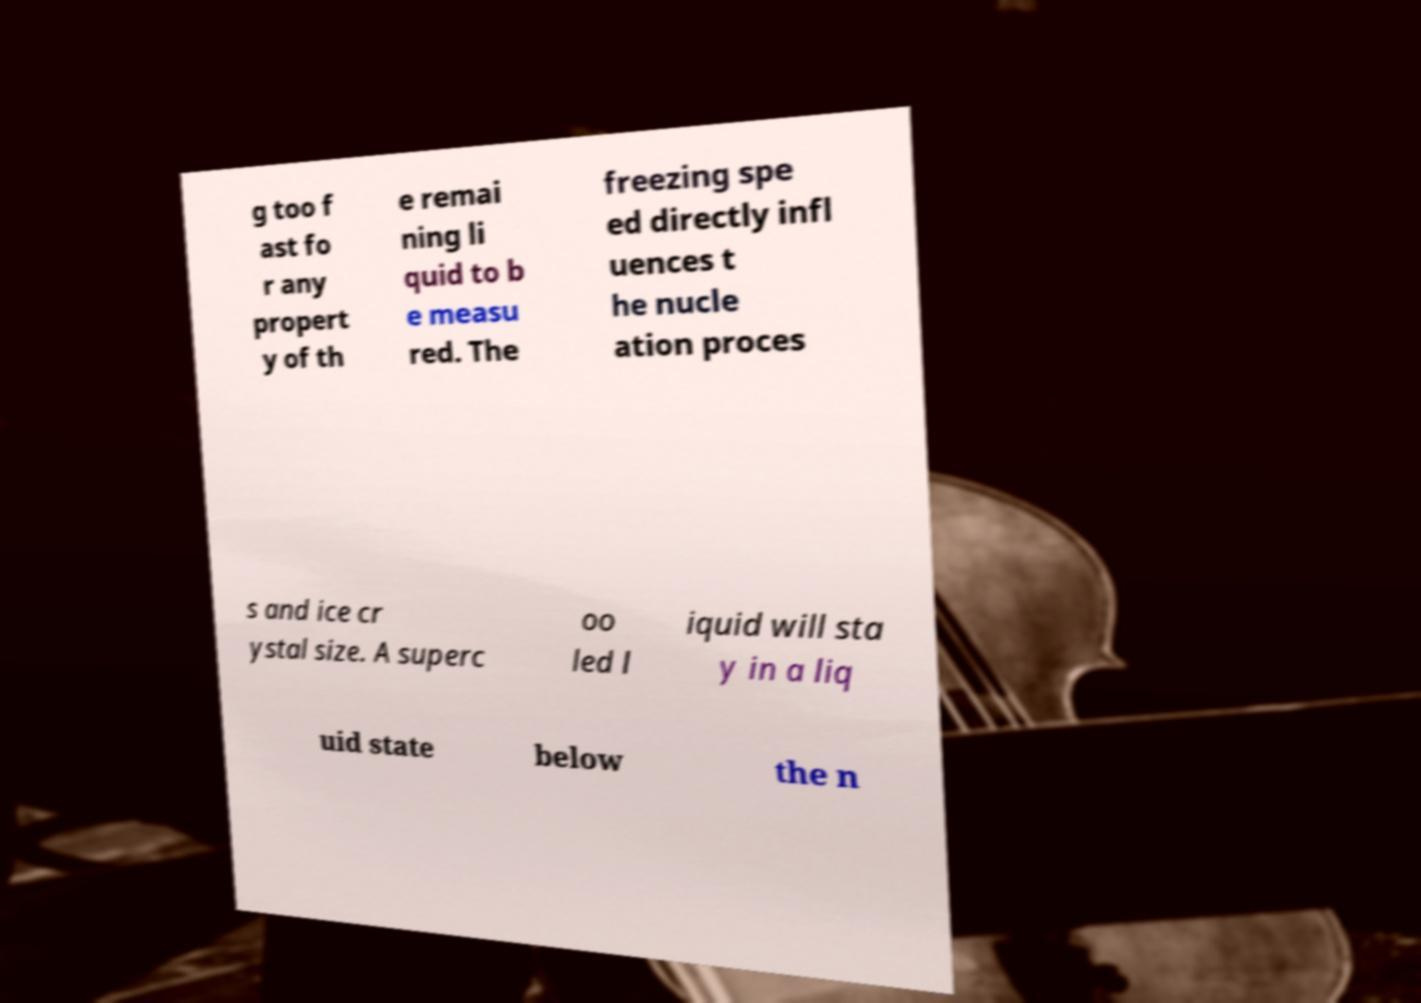Can you accurately transcribe the text from the provided image for me? g too f ast fo r any propert y of th e remai ning li quid to b e measu red. The freezing spe ed directly infl uences t he nucle ation proces s and ice cr ystal size. A superc oo led l iquid will sta y in a liq uid state below the n 